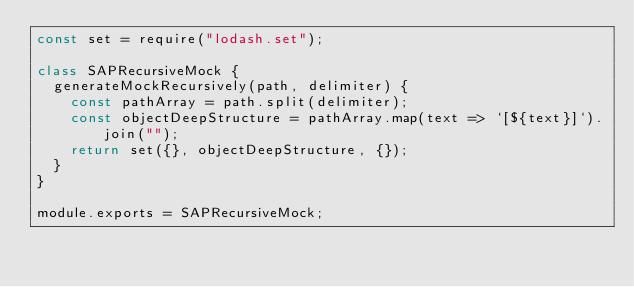Convert code to text. <code><loc_0><loc_0><loc_500><loc_500><_JavaScript_>const set = require("lodash.set");

class SAPRecursiveMock {
  generateMockRecursively(path, delimiter) {
    const pathArray = path.split(delimiter);
    const objectDeepStructure = pathArray.map(text => `[${text}]`).join("");
    return set({}, objectDeepStructure, {});
  }
}

module.exports = SAPRecursiveMock;
</code> 